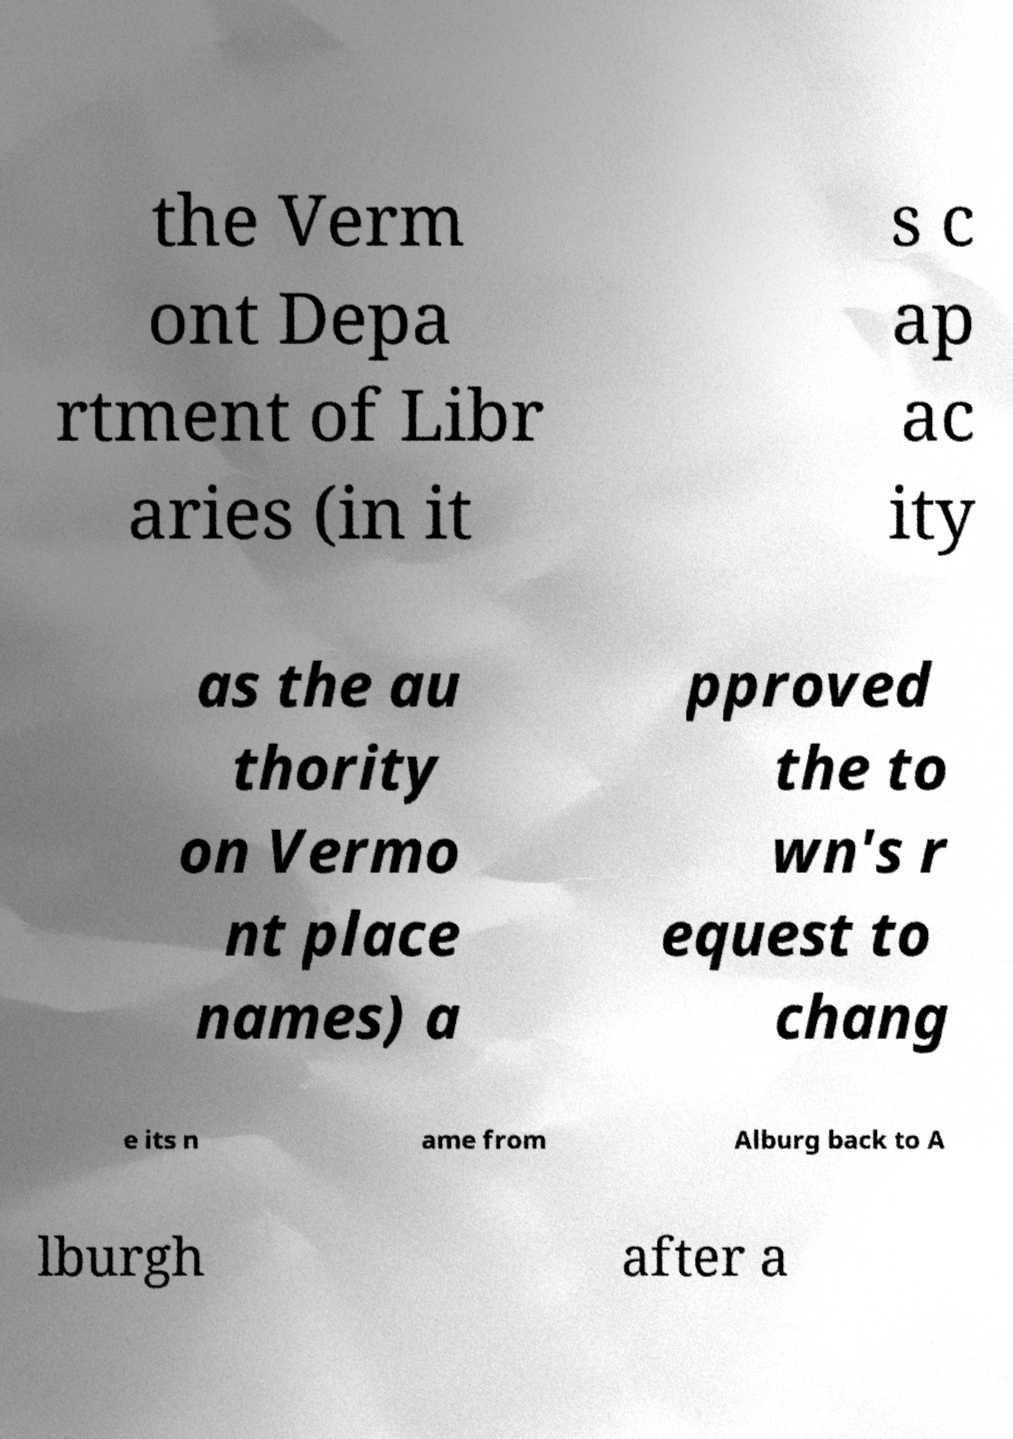Please read and relay the text visible in this image. What does it say? the Verm ont Depa rtment of Libr aries (in it s c ap ac ity as the au thority on Vermo nt place names) a pproved the to wn's r equest to chang e its n ame from Alburg back to A lburgh after a 